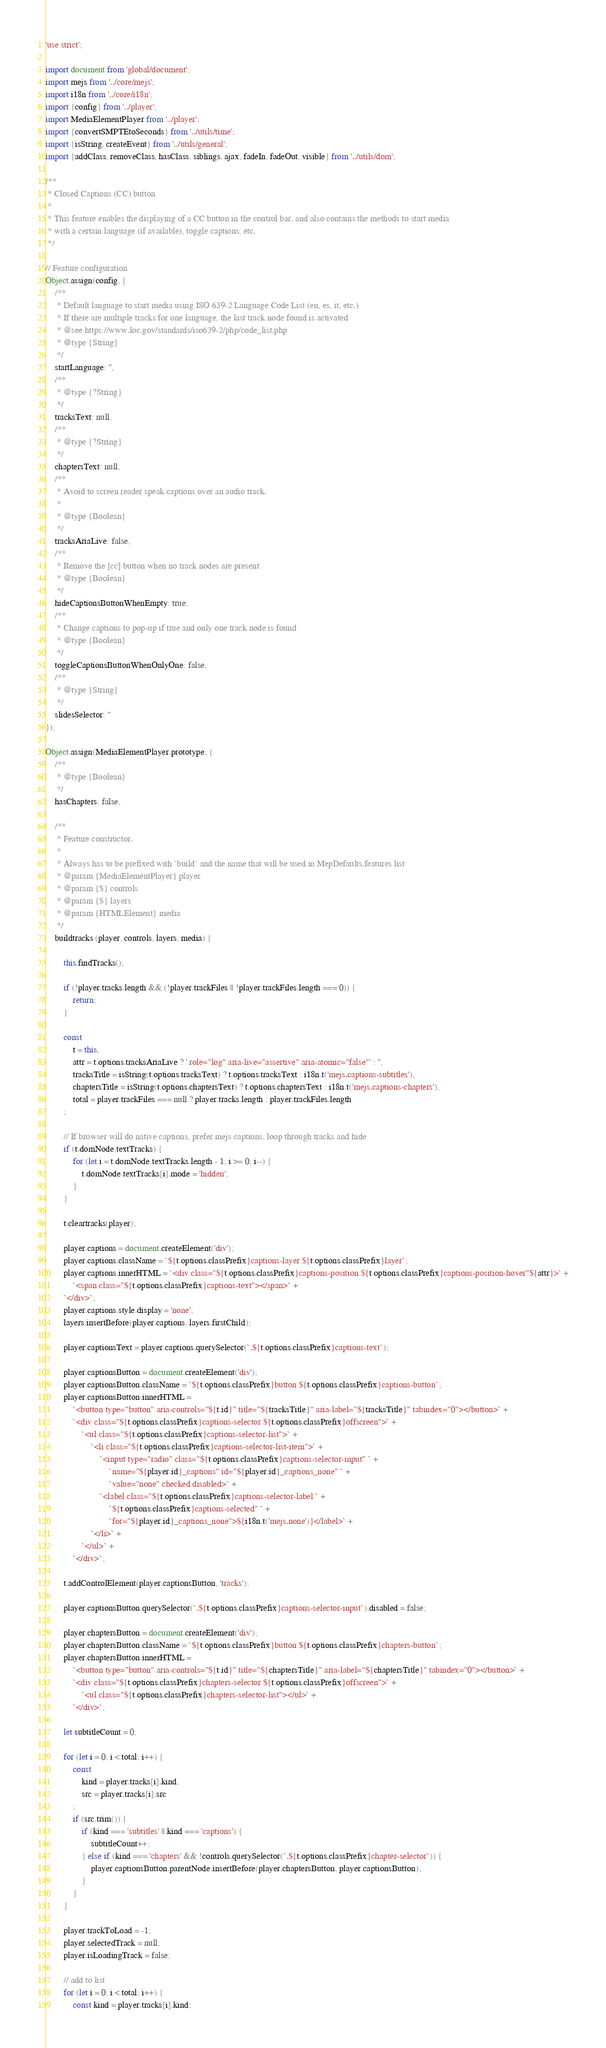<code> <loc_0><loc_0><loc_500><loc_500><_JavaScript_>'use strict';

import document from 'global/document';
import mejs from '../core/mejs';
import i18n from '../core/i18n';
import {config} from '../player';
import MediaElementPlayer from '../player';
import {convertSMPTEtoSeconds} from '../utils/time';
import {isString, createEvent} from '../utils/general';
import {addClass, removeClass, hasClass, siblings, ajax, fadeIn, fadeOut, visible} from '../utils/dom';

/**
 * Closed Captions (CC) button
 *
 * This feature enables the displaying of a CC button in the control bar, and also contains the methods to start media
 * with a certain language (if available), toggle captions, etc.
 */

// Feature configuration
Object.assign(config, {
	/**
	 * Default language to start media using ISO 639-2 Language Code List (en, es, it, etc.)
	 * If there are multiple tracks for one language, the last track node found is activated
	 * @see https://www.loc.gov/standards/iso639-2/php/code_list.php
	 * @type {String}
	 */
	startLanguage: '',
	/**
	 * @type {?String}
	 */
	tracksText: null,
	/**
	 * @type {?String}
	 */
	chaptersText: null,
	/**
	 * Avoid to screen reader speak captions over an audio track.
	 *
	 * @type {Boolean}
	 */
	tracksAriaLive: false,
	/**
	 * Remove the [cc] button when no track nodes are present
	 * @type {Boolean}
	 */
	hideCaptionsButtonWhenEmpty: true,
	/**
	 * Change captions to pop-up if true and only one track node is found
	 * @type {Boolean}
	 */
	toggleCaptionsButtonWhenOnlyOne: false,
	/**
	 * @type {String}
	 */
	slidesSelector: ''
});

Object.assign(MediaElementPlayer.prototype, {
	/**
	 * @type {Boolean}
	 */
	hasChapters: false,

	/**
	 * Feature constructor.
	 *
	 * Always has to be prefixed with `build` and the name that will be used in MepDefaults.features list
	 * @param {MediaElementPlayer} player
	 * @param {$} controls
	 * @param {$} layers
	 * @param {HTMLElement} media
	 */
	buildtracks (player, controls, layers, media) {

		this.findTracks();

		if (!player.tracks.length && (!player.trackFiles || !player.trackFiles.length === 0)) {
			return;
		}

		const
			t = this,
			attr = t.options.tracksAriaLive ? ' role="log" aria-live="assertive" aria-atomic="false"' : '',
			tracksTitle = isString(t.options.tracksText) ? t.options.tracksText : i18n.t('mejs.captions-subtitles'),
			chaptersTitle = isString(t.options.chaptersText) ? t.options.chaptersText : i18n.t('mejs.captions-chapters'),
			total = player.trackFiles === null ? player.tracks.length : player.trackFiles.length
		;

		// If browser will do native captions, prefer mejs captions, loop through tracks and hide
		if (t.domNode.textTracks) {
			for (let i = t.domNode.textTracks.length - 1; i >= 0; i--) {
				t.domNode.textTracks[i].mode = 'hidden';
			}
		}

		t.cleartracks(player);

		player.captions = document.createElement('div');
		player.captions.className = `${t.options.classPrefix}captions-layer ${t.options.classPrefix}layer`;
		player.captions.innerHTML = `<div class="${t.options.classPrefix}captions-position ${t.options.classPrefix}captions-position-hover"${attr}>` +
			`<span class="${t.options.classPrefix}captions-text"></span>` +
		`</div>`;
		player.captions.style.display = 'none';
		layers.insertBefore(player.captions, layers.firstChild);

		player.captionsText = player.captions.querySelector(`.${t.options.classPrefix}captions-text`);

		player.captionsButton = document.createElement('div');
		player.captionsButton.className = `${t.options.classPrefix}button ${t.options.classPrefix}captions-button`;
		player.captionsButton.innerHTML =
			`<button type="button" aria-controls="${t.id}" title="${tracksTitle}" aria-label="${tracksTitle}" tabindex="0"></button>` +
			`<div class="${t.options.classPrefix}captions-selector ${t.options.classPrefix}offscreen">` +
				`<ul class="${t.options.classPrefix}captions-selector-list">` +
					`<li class="${t.options.classPrefix}captions-selector-list-item">` +
						`<input type="radio" class="${t.options.classPrefix}captions-selector-input" ` +
							`name="${player.id}_captions" id="${player.id}_captions_none" ` +
							`value="none" checked disabled>` +
						`<label class="${t.options.classPrefix}captions-selector-label ` +
							`${t.options.classPrefix}captions-selected" ` +
							`for="${player.id}_captions_none">${i18n.t('mejs.none')}</label>` +
					`</li>` +
				`</ul>` +
			`</div>`;

		t.addControlElement(player.captionsButton, 'tracks');

		player.captionsButton.querySelector(`.${t.options.classPrefix}captions-selector-input`).disabled = false;

		player.chaptersButton = document.createElement('div');
		player.chaptersButton.className = `${t.options.classPrefix}button ${t.options.classPrefix}chapters-button`;
		player.chaptersButton.innerHTML =
			`<button type="button" aria-controls="${t.id}" title="${chaptersTitle}" aria-label="${chaptersTitle}" tabindex="0"></button>` +
			`<div class="${t.options.classPrefix}chapters-selector ${t.options.classPrefix}offscreen">` +
				`<ul class="${t.options.classPrefix}chapters-selector-list"></ul>` +
			`</div>`;

		let subtitleCount = 0;

		for (let i = 0; i < total; i++) {
			const
				kind = player.tracks[i].kind,
				src = player.tracks[i].src
			;
			if (src.trim()) {
				if (kind === 'subtitles' || kind === 'captions') {
					subtitleCount++;
				} else if (kind === 'chapters' && !controls.querySelector(`.${t.options.classPrefix}chapter-selector`)) {
					player.captionsButton.parentNode.insertBefore(player.chaptersButton, player.captionsButton);
				}
			}
		}

		player.trackToLoad = -1;
		player.selectedTrack = null;
		player.isLoadingTrack = false;

		// add to list
		for (let i = 0; i < total; i++) {
			const kind = player.tracks[i].kind;</code> 